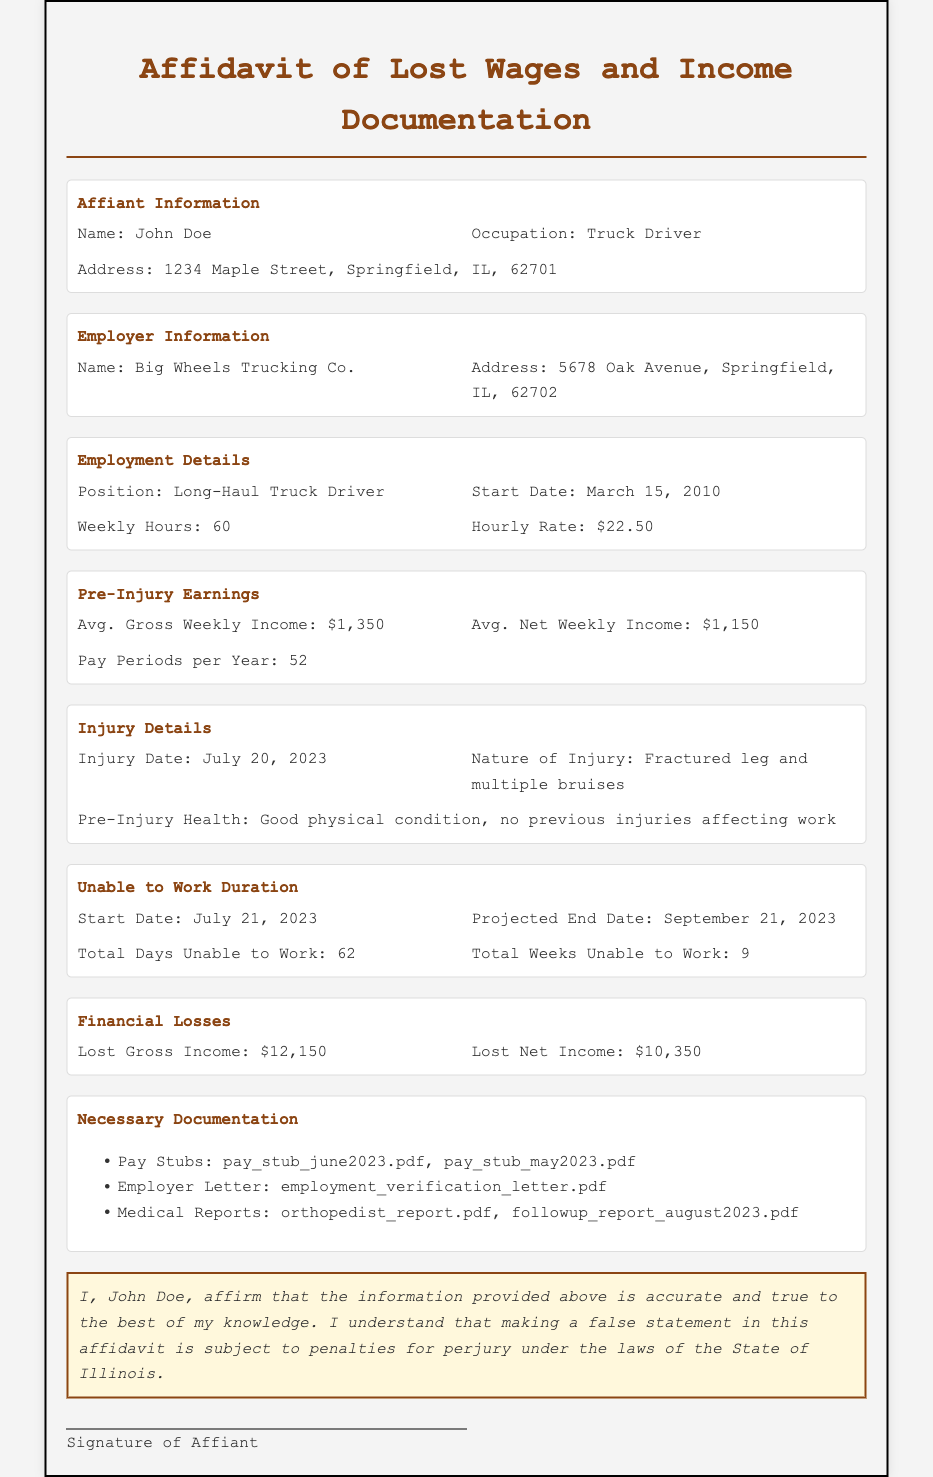What is the name of the affiant? The affiant's name is stated in the document as John Doe.
Answer: John Doe What is the occupation of the affiant? The occupation of the affiant is mentioned in the document and is specified as Truck Driver.
Answer: Truck Driver What is the total number of days the affiant was unable to work? The document states that the total days unable to work is 62.
Answer: 62 What is the injury date? The injury date is clearly provided in the document as July 20, 2023.
Answer: July 20, 2023 What is the average net weekly income of the affiant? The average net weekly income is detailed in the document and is $1,150.
Answer: $1,150 How many weeks was the affiant unable to work? The total weeks unable to work is specified as 9 in the document.
Answer: 9 What is the lost gross income according to the affidavit? The document specifies the lost gross income as $12,150.
Answer: $12,150 What is the nature of the affiant's injury? The nature of the injury is explicitly mentioned in the document as Fractured leg and multiple bruises.
Answer: Fractured leg and multiple bruises What is the employer's name? The employer's name is indicated in the document as Big Wheels Trucking Co.
Answer: Big Wheels Trucking Co 